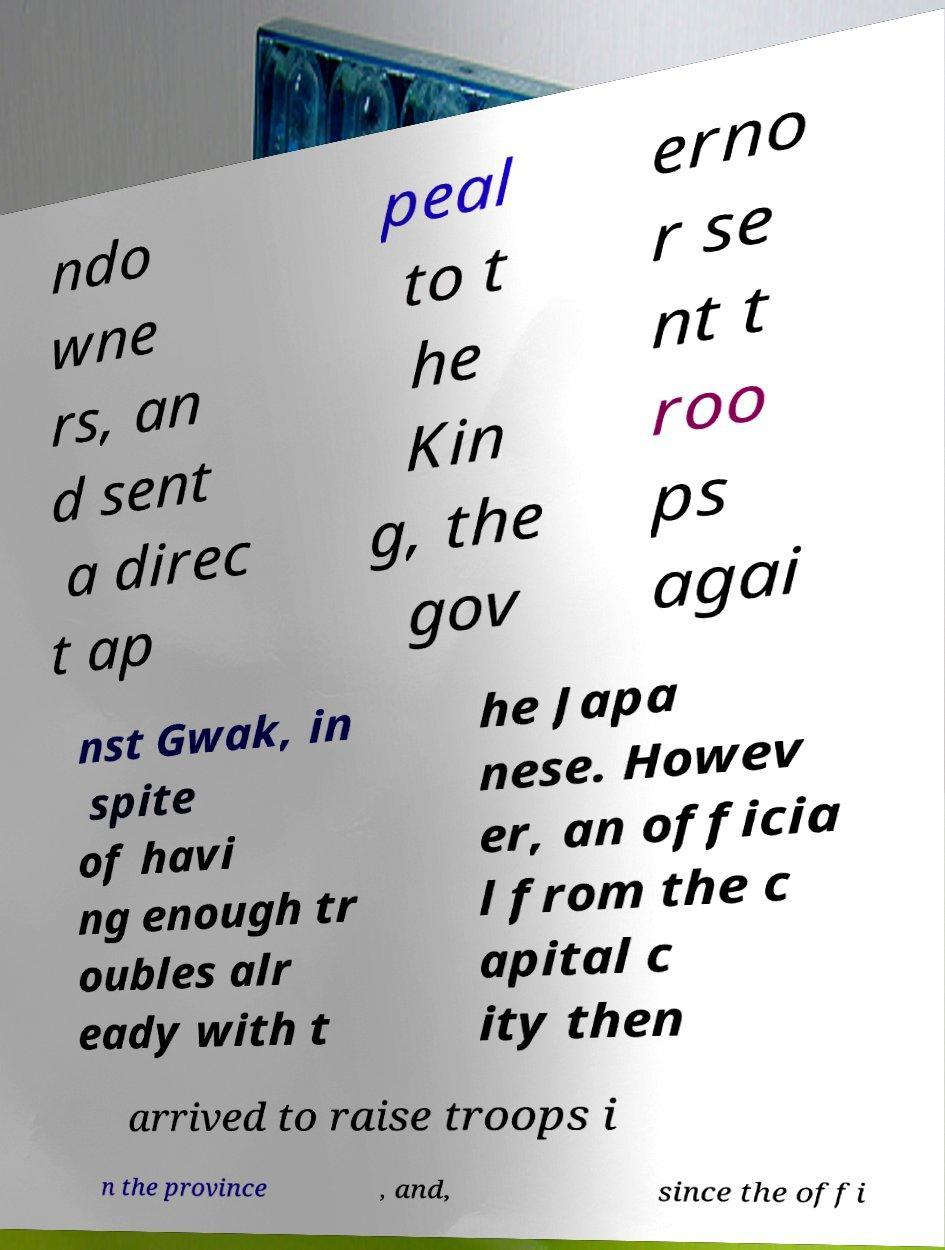Could you assist in decoding the text presented in this image and type it out clearly? ndo wne rs, an d sent a direc t ap peal to t he Kin g, the gov erno r se nt t roo ps agai nst Gwak, in spite of havi ng enough tr oubles alr eady with t he Japa nese. Howev er, an officia l from the c apital c ity then arrived to raise troops i n the province , and, since the offi 